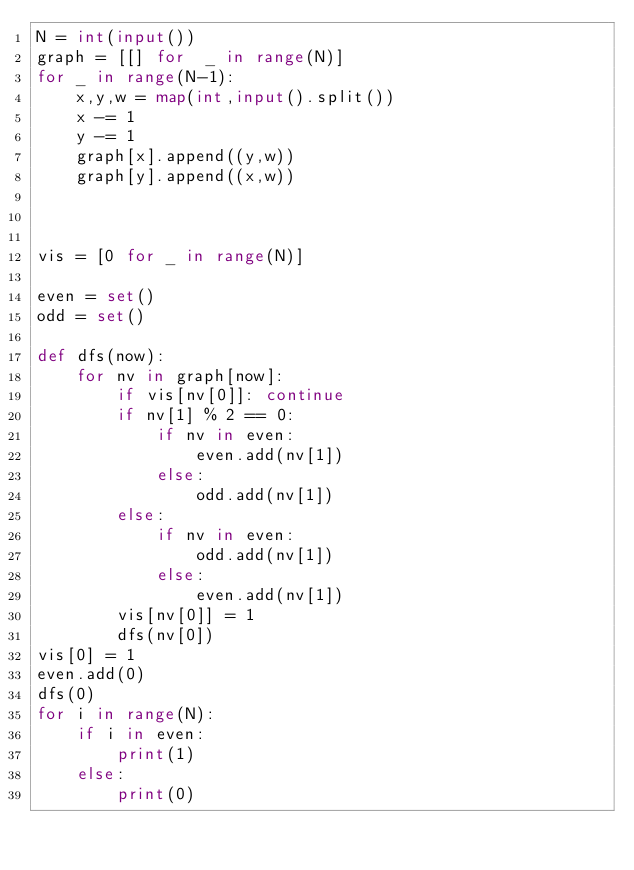Convert code to text. <code><loc_0><loc_0><loc_500><loc_500><_Python_>N = int(input())
graph = [[] for  _ in range(N)]
for _ in range(N-1):
    x,y,w = map(int,input().split())
    x -= 1
    y -= 1
    graph[x].append((y,w))
    graph[y].append((x,w))
    


vis = [0 for _ in range(N)]

even = set()
odd = set()

def dfs(now):
    for nv in graph[now]:
        if vis[nv[0]]: continue
        if nv[1] % 2 == 0:
            if nv in even:
                even.add(nv[1])
            else:
                odd.add(nv[1])
        else:
            if nv in even:
                odd.add(nv[1])
            else:
                even.add(nv[1])
        vis[nv[0]] = 1
        dfs(nv[0])
vis[0] = 1
even.add(0)
dfs(0)
for i in range(N):
    if i in even:
        print(1)
    else:
        print(0)

</code> 